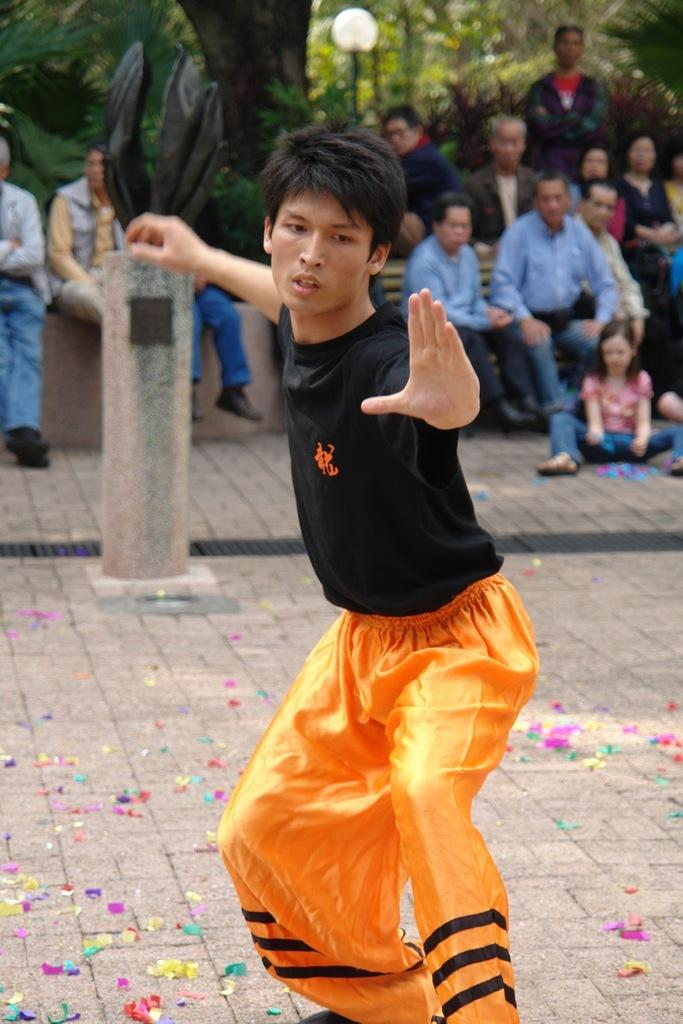What is the man in the image doing? The man in the image is performing martial arts. What is at the bottom of the image? There is a ground at the bottom of the image. What can be seen in the background of the image? There are people sitting and trees and plants are visible in the background of the image. What type of stew is being served to the people sitting in the background of the image? There is no stew present in the image; the people are sitting in the background, but no food is mentioned or visible. 